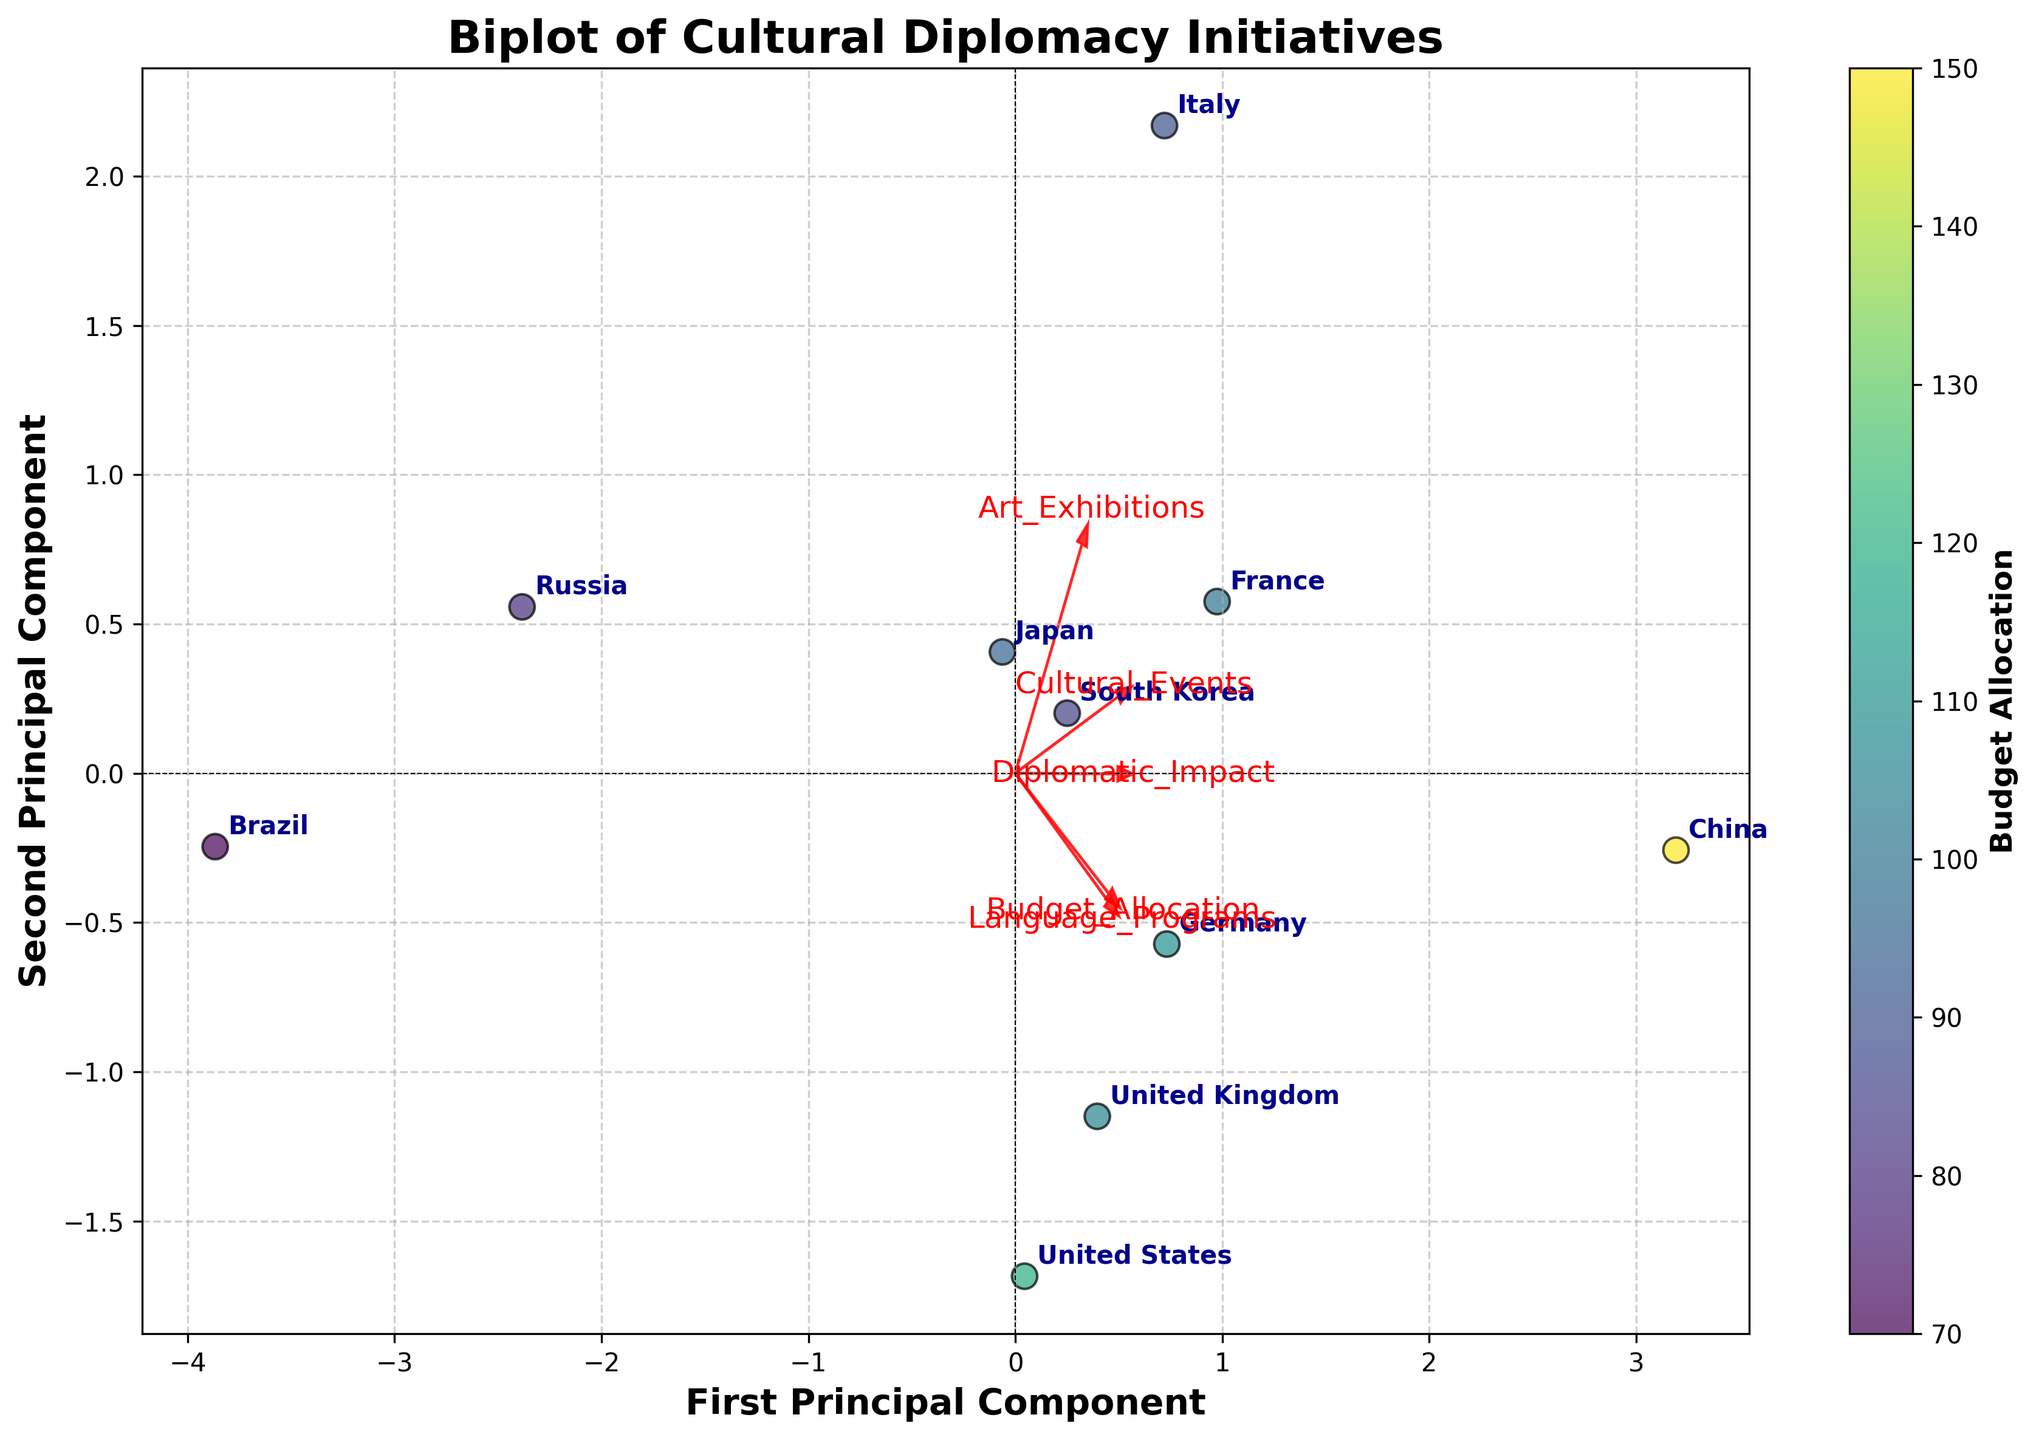How many countries are represented in the biplot? The scatter points in the biplot each represent a country. By counting the number of distinct labels, we find there are 10 different countries.
Answer: 10 Which country has the highest budget allocation? The color intensity of the scatter points corresponds to the budget allocation, with darker colors representing higher budgets. China has the darkest color, indicating the highest budget.
Answer: China Which feature appears to have the largest influence on the first principal component? The direction and length of the red arrows indicate the influence of each feature on the principal components. The "Budget Allocation" arrow is the longest and most aligned with the first principal component.
Answer: Budget Allocation Which two countries have the closest proximity on the plot? Proximity on the biplot can be observed by comparing the distances between data points. The United States and the United Kingdom are positioned very close to each other.
Answer: United States and United Kingdom What does the direction of the 'Language Programs' arrow suggest about its correlation with the principal components? The 'Language Programs' arrow points upwards and to the right. This suggests a positive correlation with both the first and second principal components.
Answer: Positive correlation with both components How does 'Cultural Events' compare to 'Diplomatic Impact' in their influence on the second principal component? By comparing the lengths and directions of their respective arrows along the second principal component axis, we observe that 'Cultural Events' has a shorter arrow pointing in a different direction compared to 'Diplomatic Impact'. Thus, 'Diplomatic Impact' has a stronger influence.
Answer: Diplomatic Impact has a stronger influence Which country is closest to zero on both principal components, and what might this suggest? South Korea is closest to the origin on both principal components. This may suggest that its cultural diplomacy initiatives are more balanced across the measured features.
Answer: South Korea How does Germany's position relate to its budget allocation compared to other countries? Germany’s scatter point color is lighter compared to countries like China and France, indicating a relatively lower budget allocation. It lies on the left side of the first principal component, suggesting it has lower budget allocation values than those countries.
Answer: Lower than China and France What relationship can be inferred between 'Budget Allocation' and 'Diplomatic Impact' based on their arrows? The arrows for 'Budget Allocation' and 'Diplomatic Impact' point somewhat in the same direction, indicating a positive correlation: higher budget allocation is associated with higher diplomatic impact.
Answer: Positive correlation Which feature has the weakest influence on the first and second principal components, and how can you tell? The shortest red arrow represents the 'Cultural Events', indicating it has the weakest influence on both principal components.
Answer: Cultural Events 